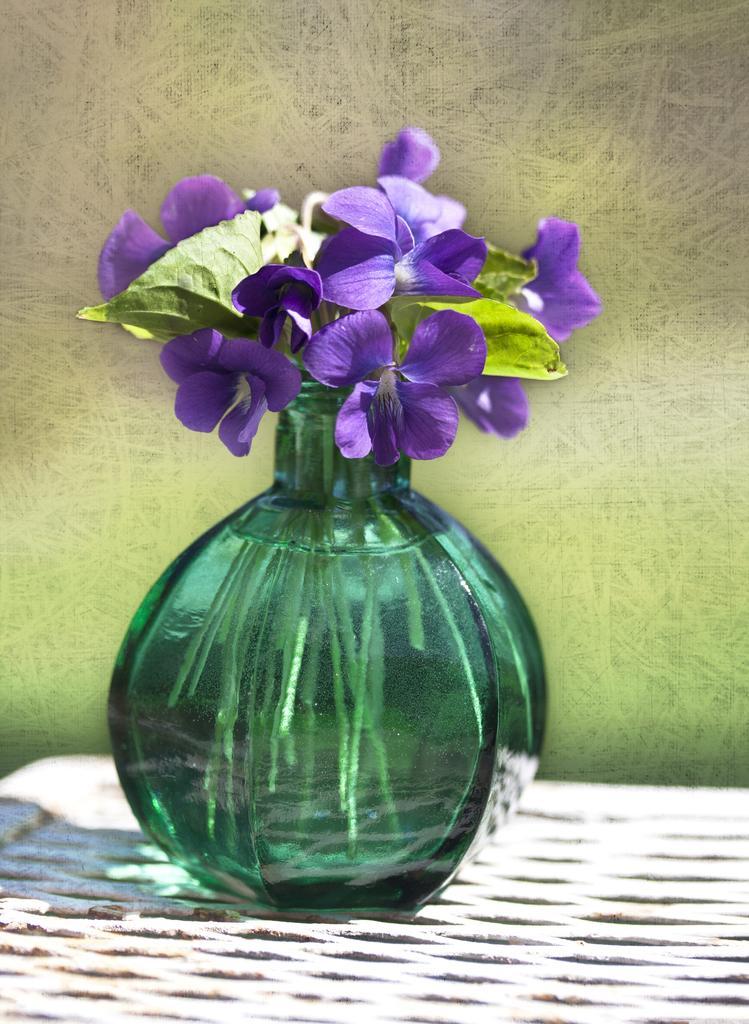In one or two sentences, can you explain what this image depicts? In this there is a flower pot with water and flowers. 